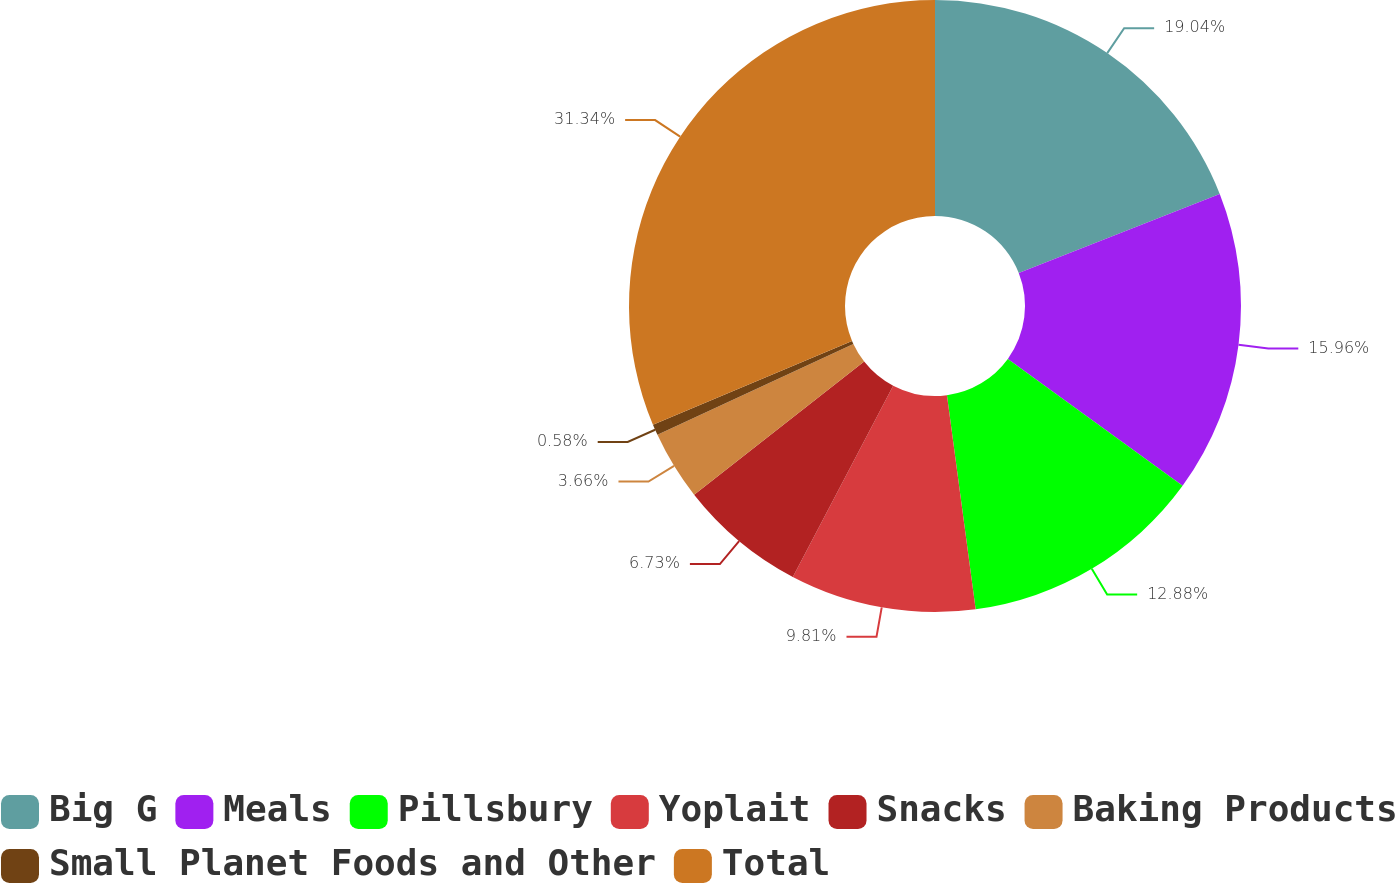Convert chart. <chart><loc_0><loc_0><loc_500><loc_500><pie_chart><fcel>Big G<fcel>Meals<fcel>Pillsbury<fcel>Yoplait<fcel>Snacks<fcel>Baking Products<fcel>Small Planet Foods and Other<fcel>Total<nl><fcel>19.03%<fcel>15.96%<fcel>12.88%<fcel>9.81%<fcel>6.73%<fcel>3.66%<fcel>0.58%<fcel>31.33%<nl></chart> 